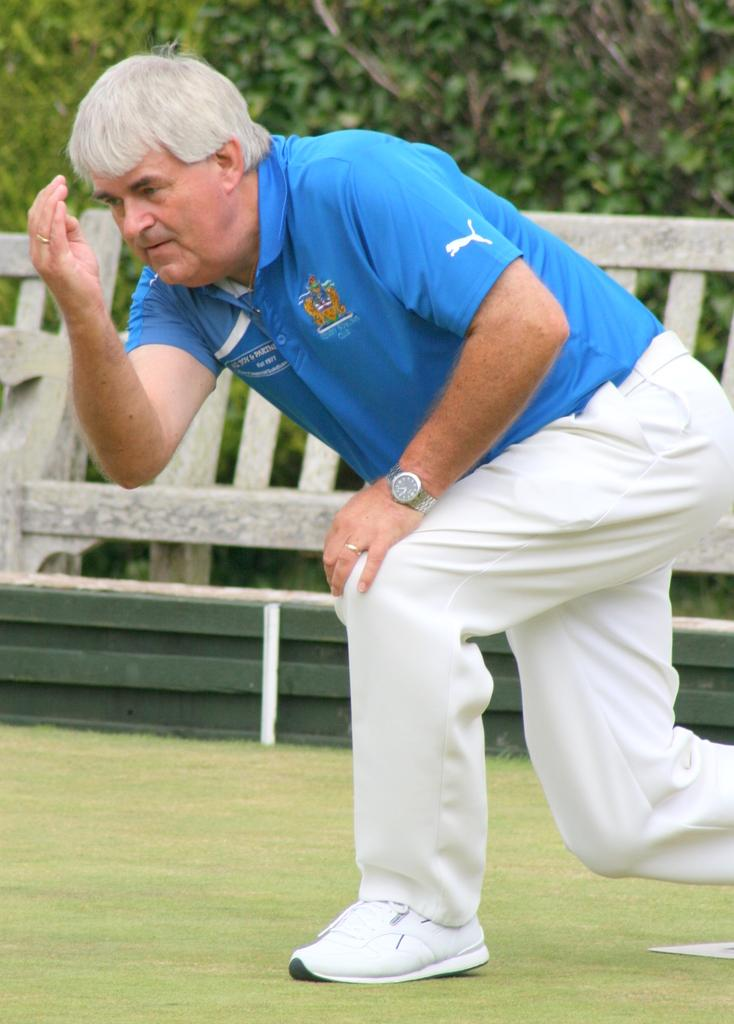Who is present in the image? There is a man in the image. What is the man wearing? The man is wearing a blue t-shirt and white pants. What can be seen in the image besides the man? There is a bench in the image. What is visible in the background of the image? There are trees visible in the background of the image. What type of produce is being exchanged on the bench in the image? There is no produce or exchange taking place in the image; it features a man sitting on a bench with trees in the background. 